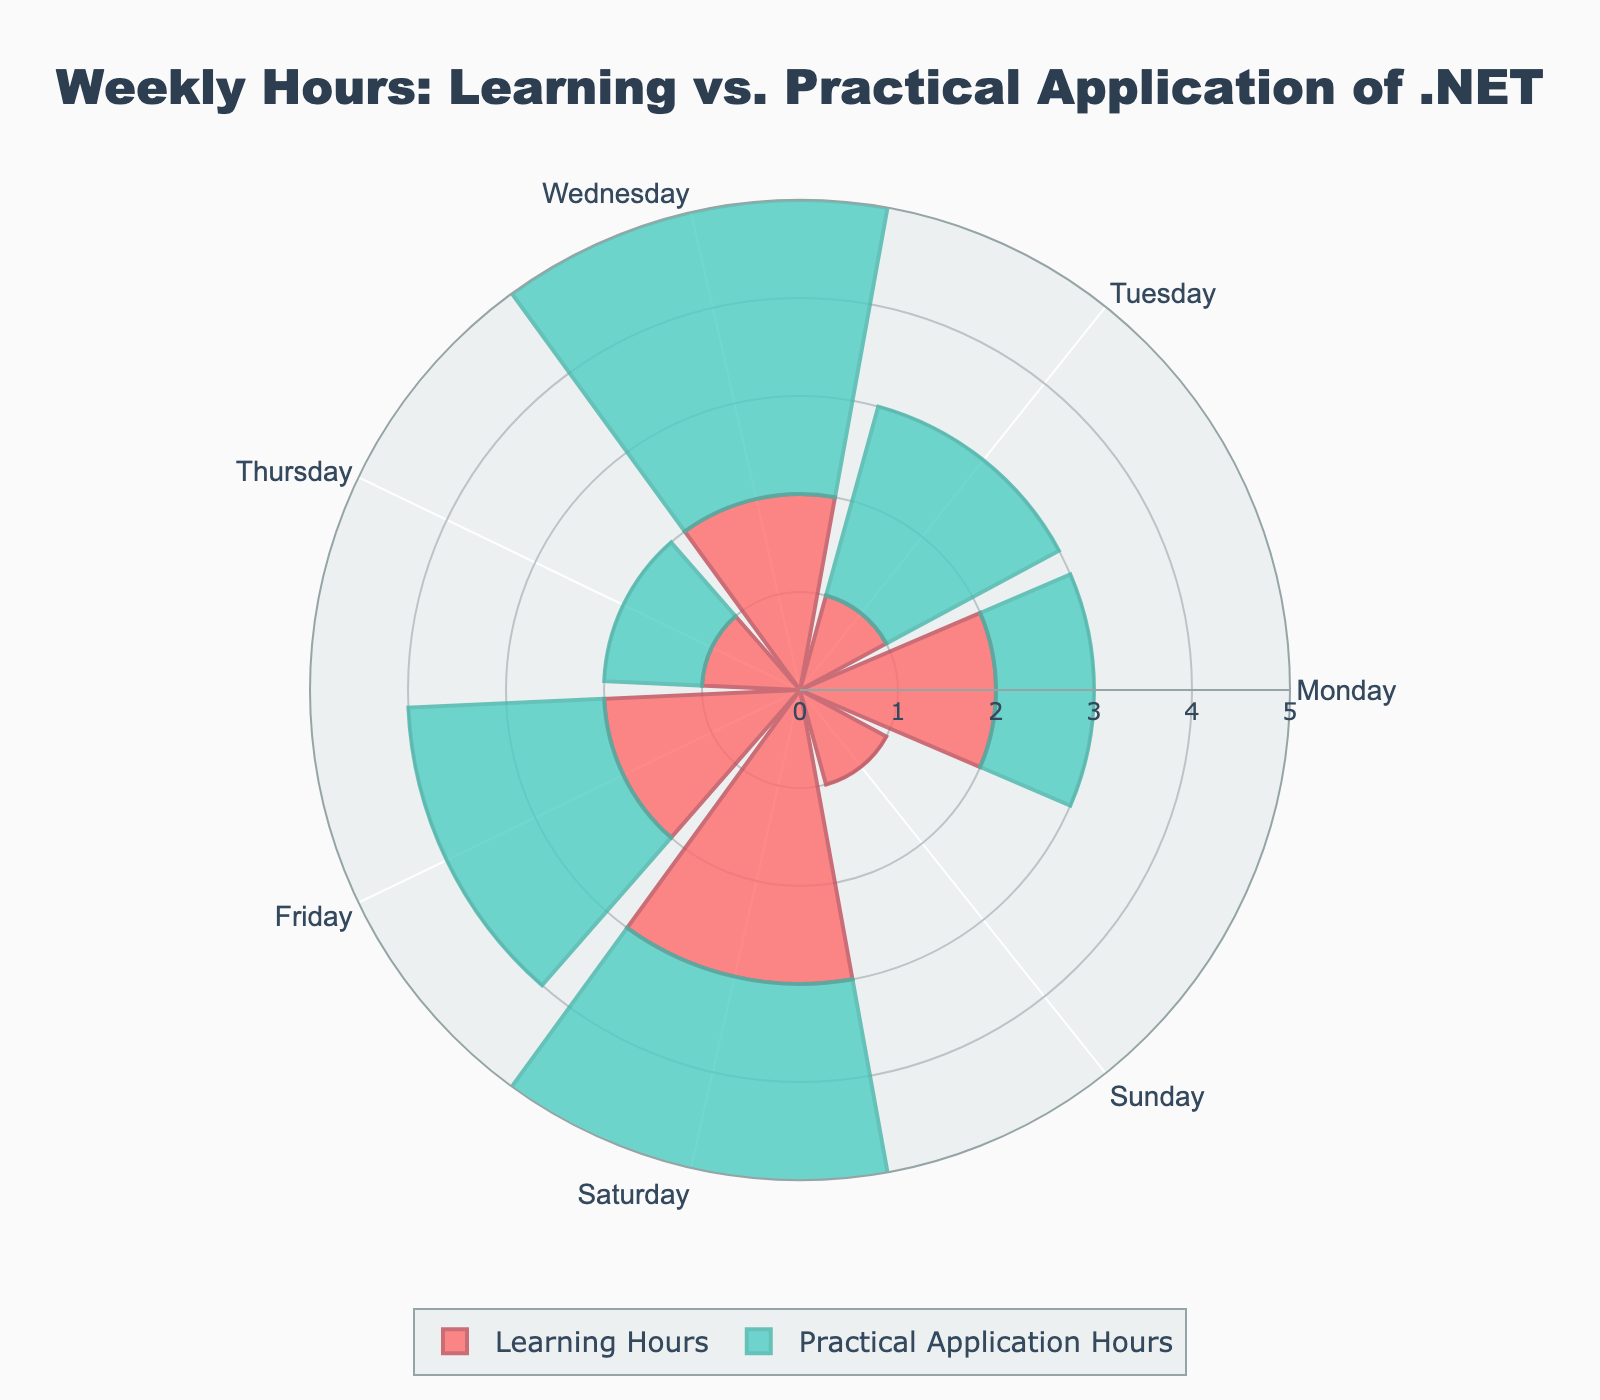What is the total number of learning hours spent on Wednesday? We look at Wednesday and pick the value for Learning Hours, which is 2 hours.
Answer: 2 Which day has the highest Practical Application Hours? We compare the Practical Application Hours for each day. Saturday has the highest value with 4 hours.
Answer: Saturday Is there any day with equal Learning and Practical Application Hours? We compare Learning and Practical Application Hours for each day. Thursday has 1 Learning Hour and 1 Practical Application Hour.
Answer: Thursday What is the difference in hours spent on Learning vs. Practical Application on Monday? On Monday, there are 2 Learning Hours and 1 Practical Application Hour. The difference is 2 - 1 = 1 hour.
Answer: 1 hour How many days have more Practical Application Hours than Learning Hours? We need to count the days where Practical Application Hours are greater than Learning Hours. Tuesday (2 > 1) and Wednesday (3 > 2) have more hours spent on practical application.
Answer: 2 days What's the total number of hours spent on Learning and Practical Application across the week? Sum up all Learning and Practical Application Hours: (2+1+2+1+2+3+1) + (1+2+3+1+2+4+0) = 12 + 13 = 25
Answer: 25 hours Which day has the least Learning Hours? We look for the smallest value in Learning Hours. Tuesday, Thursday, and Sunday each have 1 hour.
Answer: Tuesday, Thursday, Sunday What is the average Practical Application Hours per day? Sum Practical Application Hours for the week (1+2+3+1+2+4+0) = 13. Divide by 7 days to get the average: 13/7 ≈ 1.86
Answer: 1.86 hours Compare Learning Hours between Monday and Friday. On Monday, there are 2 Learning Hours, and on Friday, there are 2 Learning Hours. So, both days have equal Learning Hours.
Answer: Equal Exclude the weekday with no Practical Application Hours. What is the average Practical Application Hours for the remaining days? First, exclude Sunday with 0 hours. Sum the Practical Application Hours for Monday to Saturday (1+2+3+1+2+4) = 13. Divide by 6 days: 13/6 ≈ 2.17
Answer: 2.17 hours 